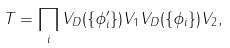Convert formula to latex. <formula><loc_0><loc_0><loc_500><loc_500>T = \prod _ { i } V _ { D } ( \{ \phi _ { i } ^ { \prime } \} ) V _ { 1 } V _ { D } ( \{ \phi _ { i } \} ) V _ { 2 } ,</formula> 